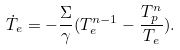<formula> <loc_0><loc_0><loc_500><loc_500>\dot { T } _ { e } = - \frac { \Sigma } { \gamma } ( T _ { e } ^ { n - 1 } - \frac { T _ { p } ^ { n } } { T _ { e } } ) .</formula> 